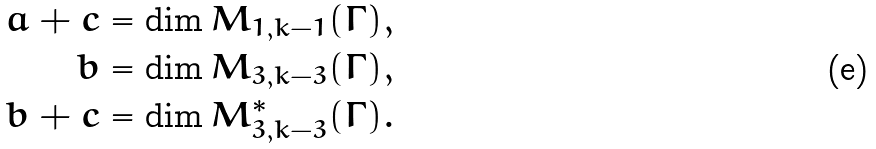<formula> <loc_0><loc_0><loc_500><loc_500>a + c & = \dim M _ { 1 , k - 1 } ( \Gamma ) , \\ b & = \dim M _ { 3 , k - 3 } ( \Gamma ) , \\ b + c & = \dim M ^ { * } _ { 3 , k - 3 } ( \Gamma ) .</formula> 